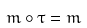<formula> <loc_0><loc_0><loc_500><loc_500>m \circ \tau = m</formula> 